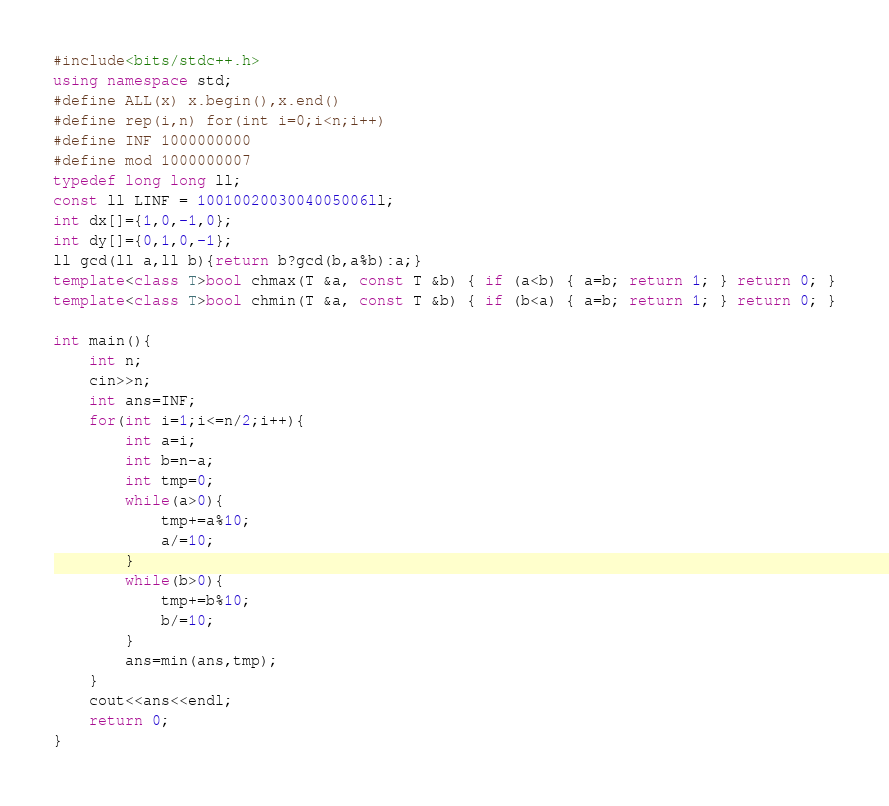Convert code to text. <code><loc_0><loc_0><loc_500><loc_500><_C++_>#include<bits/stdc++.h>
using namespace std;
#define ALL(x) x.begin(),x.end()
#define rep(i,n) for(int i=0;i<n;i++)
#define INF 1000000000
#define mod 1000000007
typedef long long ll;
const ll LINF = 1001002003004005006ll;
int dx[]={1,0,-1,0};
int dy[]={0,1,0,-1};
ll gcd(ll a,ll b){return b?gcd(b,a%b):a;}
template<class T>bool chmax(T &a, const T &b) { if (a<b) { a=b; return 1; } return 0; }
template<class T>bool chmin(T &a, const T &b) { if (b<a) { a=b; return 1; } return 0; }

int main(){
    int n;
    cin>>n;
    int ans=INF;
    for(int i=1;i<=n/2;i++){
        int a=i;
        int b=n-a;
        int tmp=0;
        while(a>0){
            tmp+=a%10;
            a/=10;
        }
        while(b>0){
            tmp+=b%10;
            b/=10;
        }
        ans=min(ans,tmp);
    }
    cout<<ans<<endl;
    return 0;
}</code> 